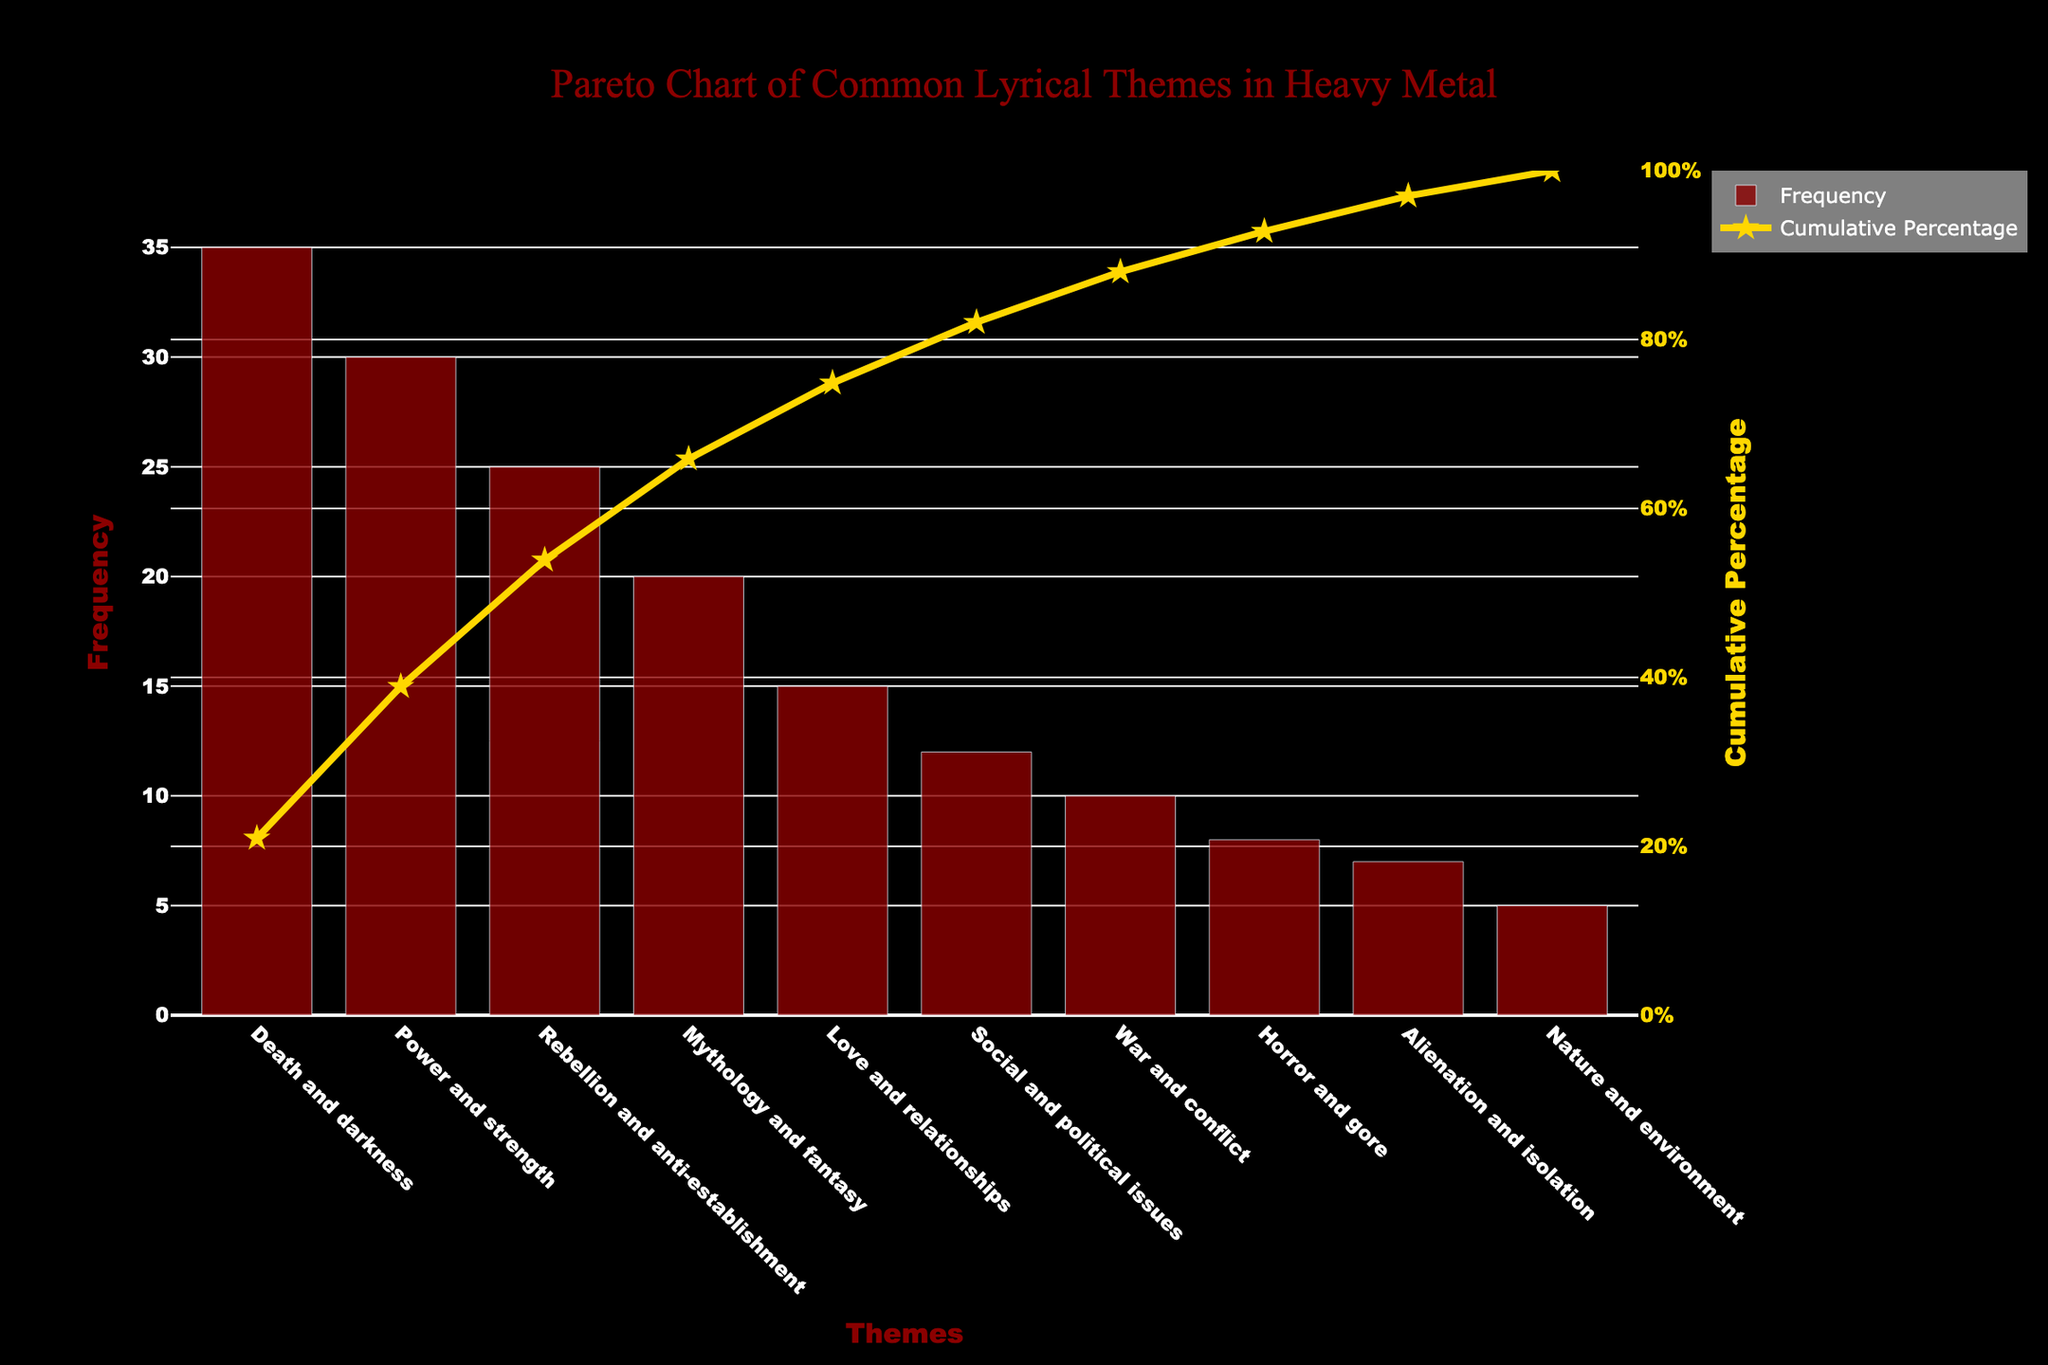What is the most prevalent lyrical theme in heavy metal music according to the figure? The most prevalent lyrical theme is represented by the tallest bar in the chart. It is "Death and darkness" with a frequency of 35.
Answer: Death and darkness What is the cumulative percentage of the top three lyrical themes? The cumulative percentage is shown as a line above the bars. For "Death and darkness" it is approximately 28%, for "Power and strength" it reaches roughly 52%, and for "Rebellion and anti-establishment" it is around 72%. So, 28% + 24% + 20% = 72%.
Answer: About 72% Which theme has a frequency of 15? The theme with a frequency of 15 can be found by locating the bar that reaches the height corresponding to 15 on the frequency axis. It is "Love and relationships".
Answer: Love and relationships What is the cumulative percentage after "Social and political issues"? The cumulative percentage line for "Social and political issues" sits approximately at 87%.
Answer: About 87% Is "War and conflict" more or less frequent than "Social and political issues"? Comparing the heights of the bars, "War and conflict" has a frequency of 10 while "Social and political issues" has a frequency of 12. Thus, "War and conflict" is less frequent.
Answer: Less frequent What is the frequency difference between the least and the most prevalent themes? The frequency of the most prevalent theme, "Death and darkness", is 35, and the frequency of the least prevalent theme, "Nature and environment", is 5. The difference is 35 - 5 = 30.
Answer: 30 What cumulative percentage does the "Mythology and fantasy" theme add when included? "Mythology and fantasy" is the fourth theme, and its cumulative percentage is around 60% when included.
Answer: About 60% How many themes are discussed in total in the chart? Counting all unique bars in the chart, there are ten distinct themes represented.
Answer: Ten Between "Horror and gore" and "Alienation and isolation," which theme is more observed in heavy metal music? By comparing the heights of these bars, "Horror and gore" has a frequency of 8, while "Alienation and isolation" has a frequency of 7, so "Horror and gore" is more observed.
Answer: Horror and gore What is the title of the chart? The title can be found at the top of the chart and reads: "Pareto Chart of Common Lyrical Themes in Heavy Metal".
Answer: Pareto Chart of Common Lyrical Themes in Heavy Metal 